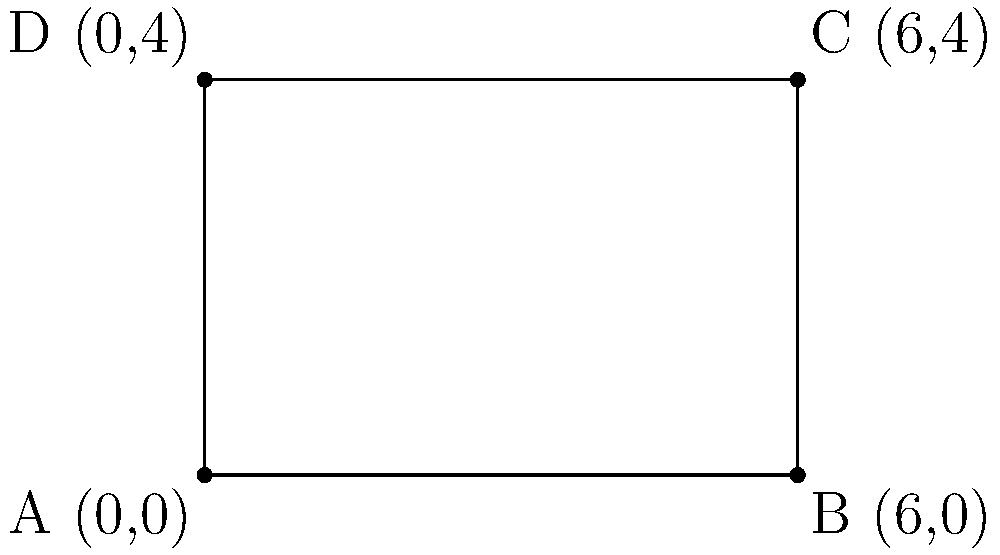In a boxing ring modeled on a coordinate plane, the corners are represented by points A(0,0), B(6,0), C(6,4), and D(0,4). What is the distance between opposite corners A and C? To find the distance between opposite corners A and C, we can use the distance formula:

$$d = \sqrt{(x_2 - x_1)^2 + (y_2 - y_1)^2}$$

Where $(x_1, y_1)$ are the coordinates of point A, and $(x_2, y_2)$ are the coordinates of point C.

Step 1: Identify the coordinates
A: $(0, 0)$
C: $(6, 4)$

Step 2: Apply the distance formula
$$d = \sqrt{(6 - 0)^2 + (4 - 0)^2}$$

Step 3: Simplify
$$d = \sqrt{6^2 + 4^2}$$
$$d = \sqrt{36 + 16}$$
$$d = \sqrt{52}$$

Step 4: Simplify the square root
$$d = 2\sqrt{13}$$

Therefore, the distance between opposite corners A and C in the boxing ring is $2\sqrt{13}$ units.
Answer: $2\sqrt{13}$ units 